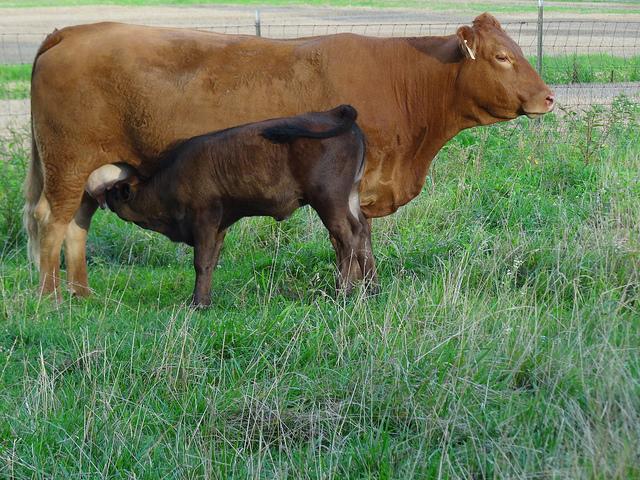Are there trees?
Keep it brief. No. What is the baby doing?
Give a very brief answer. Nursing. What color is the cow in front?
Write a very short answer. Brown. How many adult animals in this photo?
Short answer required. 1. What animals are they?
Answer briefly. Cows. 